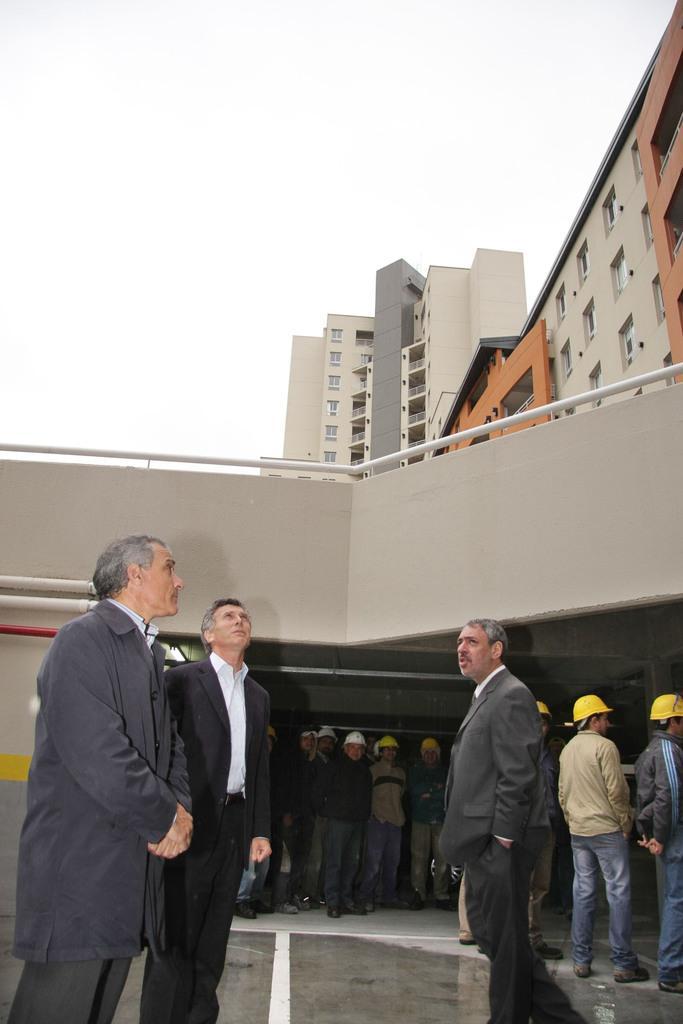Describe this image in one or two sentences. On the left side, there are two persons watching something. On the right side, there is a person in a suit, speaking and walking. In the background, there are other persons under a roof, there are buildings and there are clouds in the sky. 